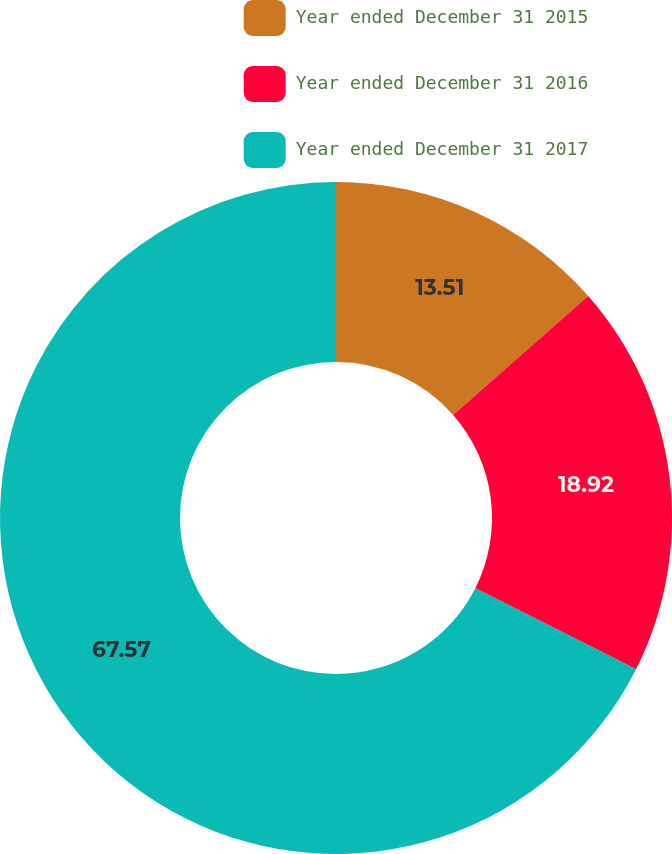<chart> <loc_0><loc_0><loc_500><loc_500><pie_chart><fcel>Year ended December 31 2015<fcel>Year ended December 31 2016<fcel>Year ended December 31 2017<nl><fcel>13.51%<fcel>18.92%<fcel>67.57%<nl></chart> 